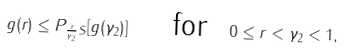Convert formula to latex. <formula><loc_0><loc_0><loc_500><loc_500>g ( r ) \leq { P } _ { \frac { r } { \gamma _ { 2 } } S } [ g ( \gamma _ { 2 } ) ] \quad \text { for } \ 0 \leq r < \gamma _ { 2 } < 1 ,</formula> 